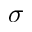<formula> <loc_0><loc_0><loc_500><loc_500>\sigma</formula> 